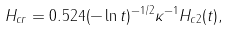Convert formula to latex. <formula><loc_0><loc_0><loc_500><loc_500>H _ { c r } = 0 . 5 2 4 ( - \ln t ) ^ { - 1 / 2 } \kappa ^ { - 1 } H _ { c 2 } ( t ) ,</formula> 